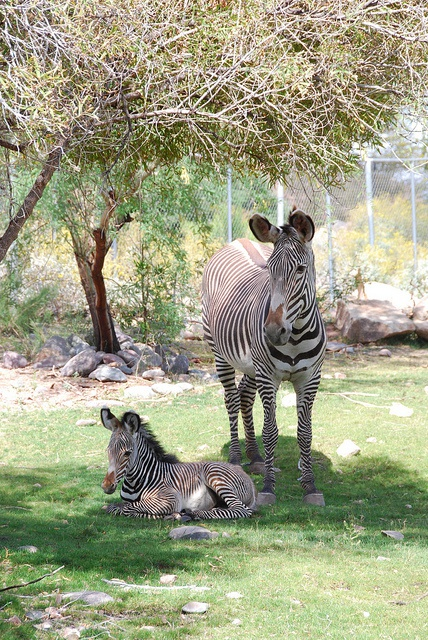Describe the objects in this image and their specific colors. I can see zebra in gray, darkgray, black, and lightgray tones and zebra in gray, black, darkgray, and lightgray tones in this image. 